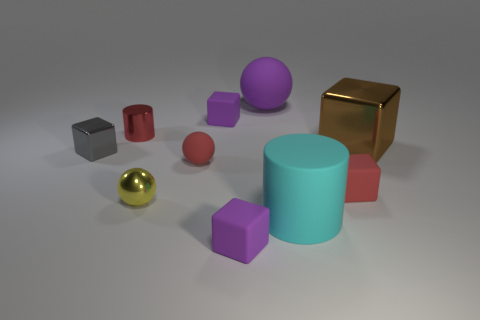There is a red matte object left of the big thing behind the shiny thing right of the big purple object; what shape is it?
Ensure brevity in your answer.  Sphere. What number of cyan things are big rubber things or big matte balls?
Your answer should be compact. 1. There is a small purple thing behind the red sphere; how many purple objects are on the right side of it?
Offer a terse response. 2. Is there any other thing that has the same color as the small metal sphere?
Offer a very short reply. No. The red thing that is made of the same material as the large brown object is what shape?
Make the answer very short. Cylinder. Do the small rubber sphere and the small cylinder have the same color?
Your answer should be very brief. Yes. Does the cylinder that is to the left of the red sphere have the same material as the tiny block left of the yellow shiny ball?
Give a very brief answer. Yes. What number of things are metal cubes or small red things that are left of the purple rubber ball?
Provide a succinct answer. 4. There is a tiny rubber thing that is the same color as the small rubber sphere; what is its shape?
Offer a very short reply. Cube. What is the material of the gray cube?
Make the answer very short. Metal. 